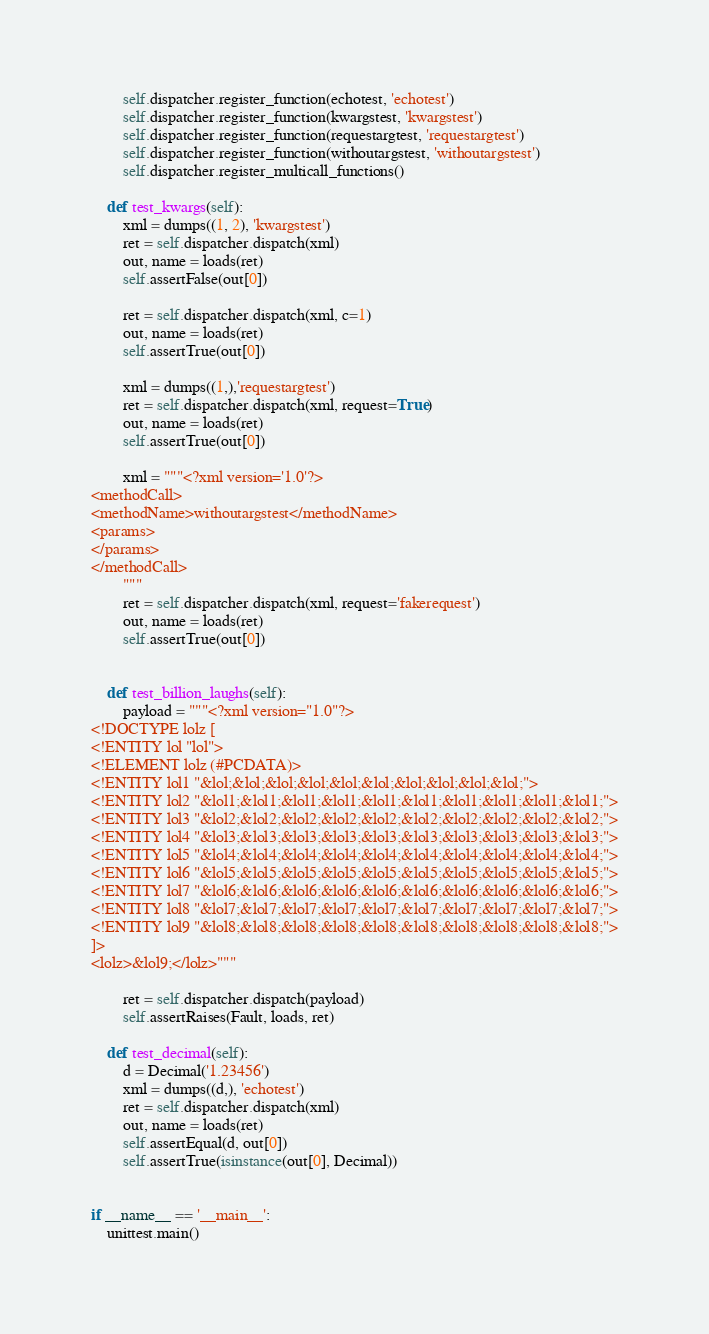Convert code to text. <code><loc_0><loc_0><loc_500><loc_500><_Python_>        self.dispatcher.register_function(echotest, 'echotest')
        self.dispatcher.register_function(kwargstest, 'kwargstest')
        self.dispatcher.register_function(requestargtest, 'requestargtest')
        self.dispatcher.register_function(withoutargstest, 'withoutargstest')
        self.dispatcher.register_multicall_functions()
        
    def test_kwargs(self):
        xml = dumps((1, 2), 'kwargstest')
        ret = self.dispatcher.dispatch(xml)
        out, name = loads(ret)
        self.assertFalse(out[0])

        ret = self.dispatcher.dispatch(xml, c=1)
        out, name = loads(ret)
        self.assertTrue(out[0])
        
        xml = dumps((1,),'requestargtest')
        ret = self.dispatcher.dispatch(xml, request=True)
        out, name = loads(ret)
        self.assertTrue(out[0])
        
        xml = """<?xml version='1.0'?>
<methodCall>
<methodName>withoutargstest</methodName>
<params>
</params>
</methodCall>
        """
        ret = self.dispatcher.dispatch(xml, request='fakerequest')
        out, name = loads(ret)
        self.assertTrue(out[0])
        

    def test_billion_laughs(self):
        payload = """<?xml version="1.0"?>
<!DOCTYPE lolz [
<!ENTITY lol "lol">
<!ELEMENT lolz (#PCDATA)>
<!ENTITY lol1 "&lol;&lol;&lol;&lol;&lol;&lol;&lol;&lol;&lol;&lol;">
<!ENTITY lol2 "&lol1;&lol1;&lol1;&lol1;&lol1;&lol1;&lol1;&lol1;&lol1;&lol1;">
<!ENTITY lol3 "&lol2;&lol2;&lol2;&lol2;&lol2;&lol2;&lol2;&lol2;&lol2;&lol2;">
<!ENTITY lol4 "&lol3;&lol3;&lol3;&lol3;&lol3;&lol3;&lol3;&lol3;&lol3;&lol3;">
<!ENTITY lol5 "&lol4;&lol4;&lol4;&lol4;&lol4;&lol4;&lol4;&lol4;&lol4;&lol4;">
<!ENTITY lol6 "&lol5;&lol5;&lol5;&lol5;&lol5;&lol5;&lol5;&lol5;&lol5;&lol5;">
<!ENTITY lol7 "&lol6;&lol6;&lol6;&lol6;&lol6;&lol6;&lol6;&lol6;&lol6;&lol6;">
<!ENTITY lol8 "&lol7;&lol7;&lol7;&lol7;&lol7;&lol7;&lol7;&lol7;&lol7;&lol7;">
<!ENTITY lol9 "&lol8;&lol8;&lol8;&lol8;&lol8;&lol8;&lol8;&lol8;&lol8;&lol8;">
]>
<lolz>&lol9;</lolz>"""

        ret = self.dispatcher.dispatch(payload)
        self.assertRaises(Fault, loads, ret)

    def test_decimal(self):
        d = Decimal('1.23456')
        xml = dumps((d,), 'echotest')
        ret = self.dispatcher.dispatch(xml)
        out, name = loads(ret)
        self.assertEqual(d, out[0])
        self.assertTrue(isinstance(out[0], Decimal))
    
                                        
if __name__ == '__main__':
    unittest.main()
</code> 